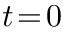<formula> <loc_0><loc_0><loc_500><loc_500>t \, = \, 0</formula> 